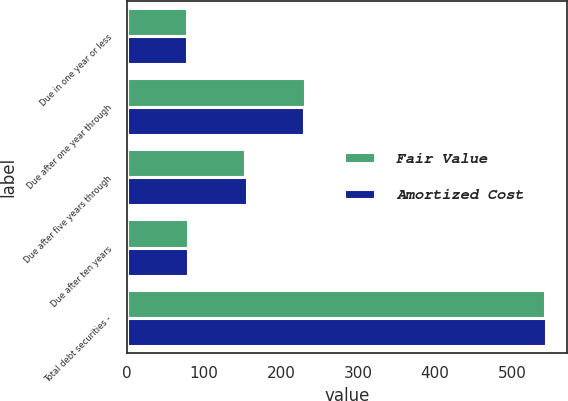Convert chart to OTSL. <chart><loc_0><loc_0><loc_500><loc_500><stacked_bar_chart><ecel><fcel>Due in one year or less<fcel>Due after one year through<fcel>Due after five years through<fcel>Due after ten years<fcel>Total debt securities -<nl><fcel>Fair Value<fcel>78<fcel>231<fcel>154<fcel>80<fcel>543<nl><fcel>Amortized Cost<fcel>78<fcel>230<fcel>156<fcel>80<fcel>544<nl></chart> 